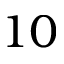<formula> <loc_0><loc_0><loc_500><loc_500>1 0</formula> 